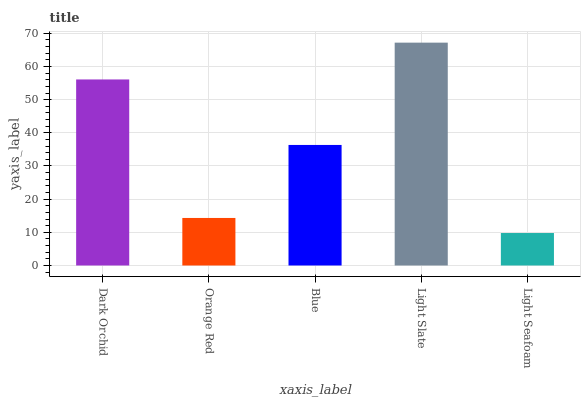Is Light Seafoam the minimum?
Answer yes or no. Yes. Is Light Slate the maximum?
Answer yes or no. Yes. Is Orange Red the minimum?
Answer yes or no. No. Is Orange Red the maximum?
Answer yes or no. No. Is Dark Orchid greater than Orange Red?
Answer yes or no. Yes. Is Orange Red less than Dark Orchid?
Answer yes or no. Yes. Is Orange Red greater than Dark Orchid?
Answer yes or no. No. Is Dark Orchid less than Orange Red?
Answer yes or no. No. Is Blue the high median?
Answer yes or no. Yes. Is Blue the low median?
Answer yes or no. Yes. Is Dark Orchid the high median?
Answer yes or no. No. Is Orange Red the low median?
Answer yes or no. No. 